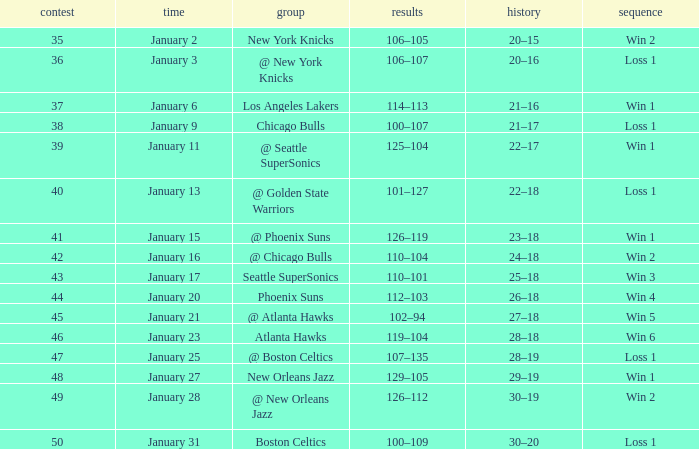What is the Team in Game 41? @ Phoenix Suns. 